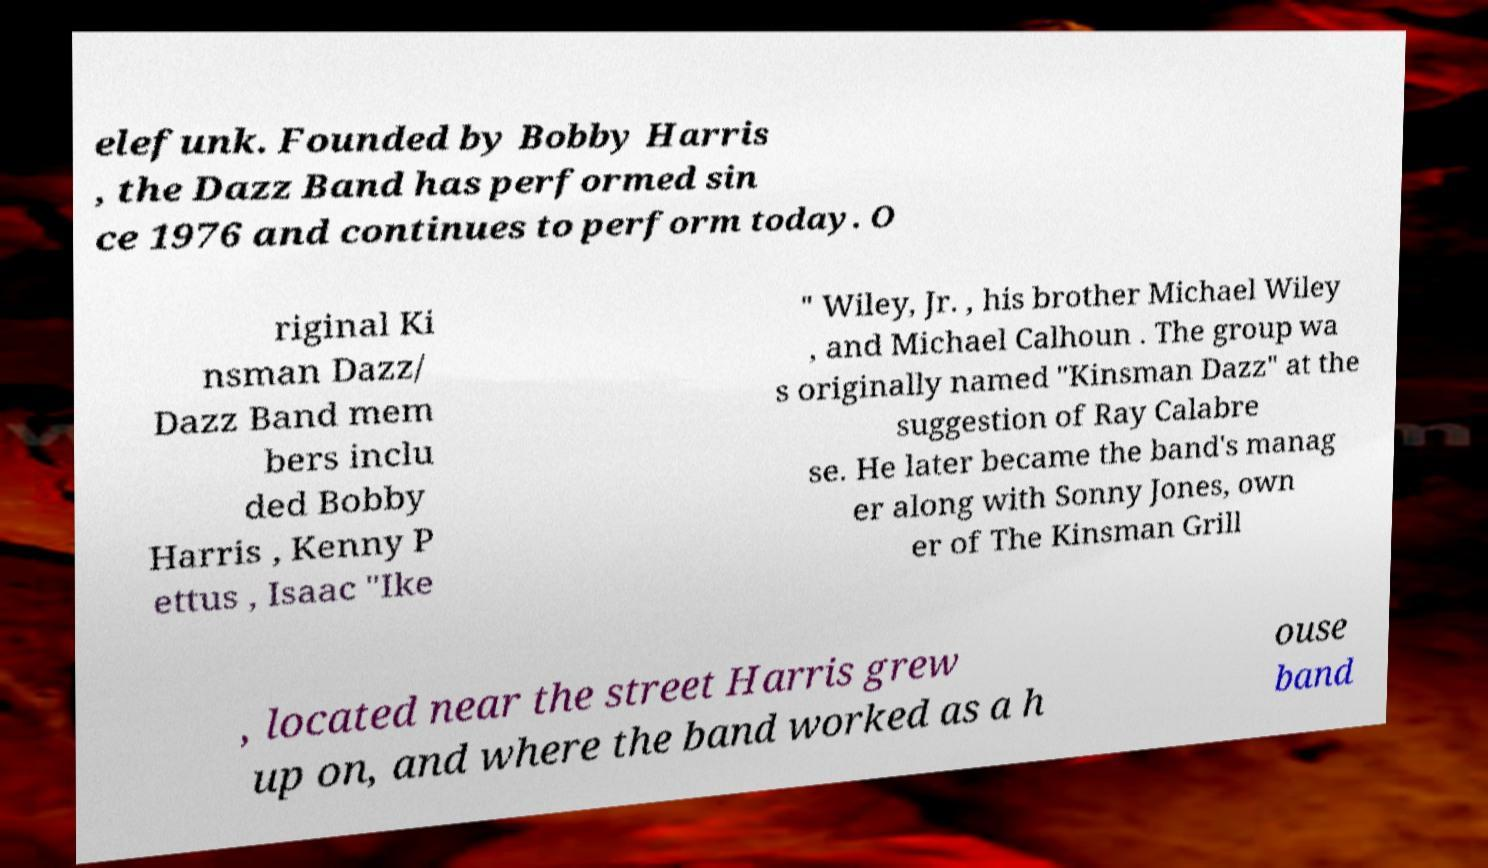For documentation purposes, I need the text within this image transcribed. Could you provide that? elefunk. Founded by Bobby Harris , the Dazz Band has performed sin ce 1976 and continues to perform today. O riginal Ki nsman Dazz/ Dazz Band mem bers inclu ded Bobby Harris , Kenny P ettus , Isaac "Ike " Wiley, Jr. , his brother Michael Wiley , and Michael Calhoun . The group wa s originally named "Kinsman Dazz" at the suggestion of Ray Calabre se. He later became the band's manag er along with Sonny Jones, own er of The Kinsman Grill , located near the street Harris grew up on, and where the band worked as a h ouse band 